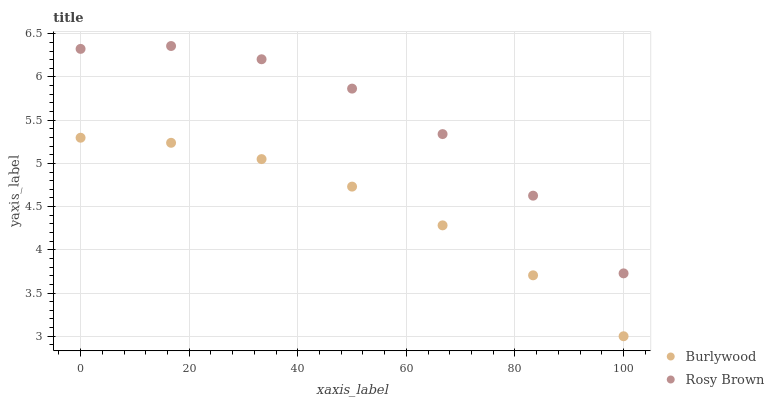Does Burlywood have the minimum area under the curve?
Answer yes or no. Yes. Does Rosy Brown have the maximum area under the curve?
Answer yes or no. Yes. Does Rosy Brown have the minimum area under the curve?
Answer yes or no. No. Is Burlywood the smoothest?
Answer yes or no. Yes. Is Rosy Brown the roughest?
Answer yes or no. Yes. Is Rosy Brown the smoothest?
Answer yes or no. No. Does Burlywood have the lowest value?
Answer yes or no. Yes. Does Rosy Brown have the lowest value?
Answer yes or no. No. Does Rosy Brown have the highest value?
Answer yes or no. Yes. Is Burlywood less than Rosy Brown?
Answer yes or no. Yes. Is Rosy Brown greater than Burlywood?
Answer yes or no. Yes. Does Burlywood intersect Rosy Brown?
Answer yes or no. No. 